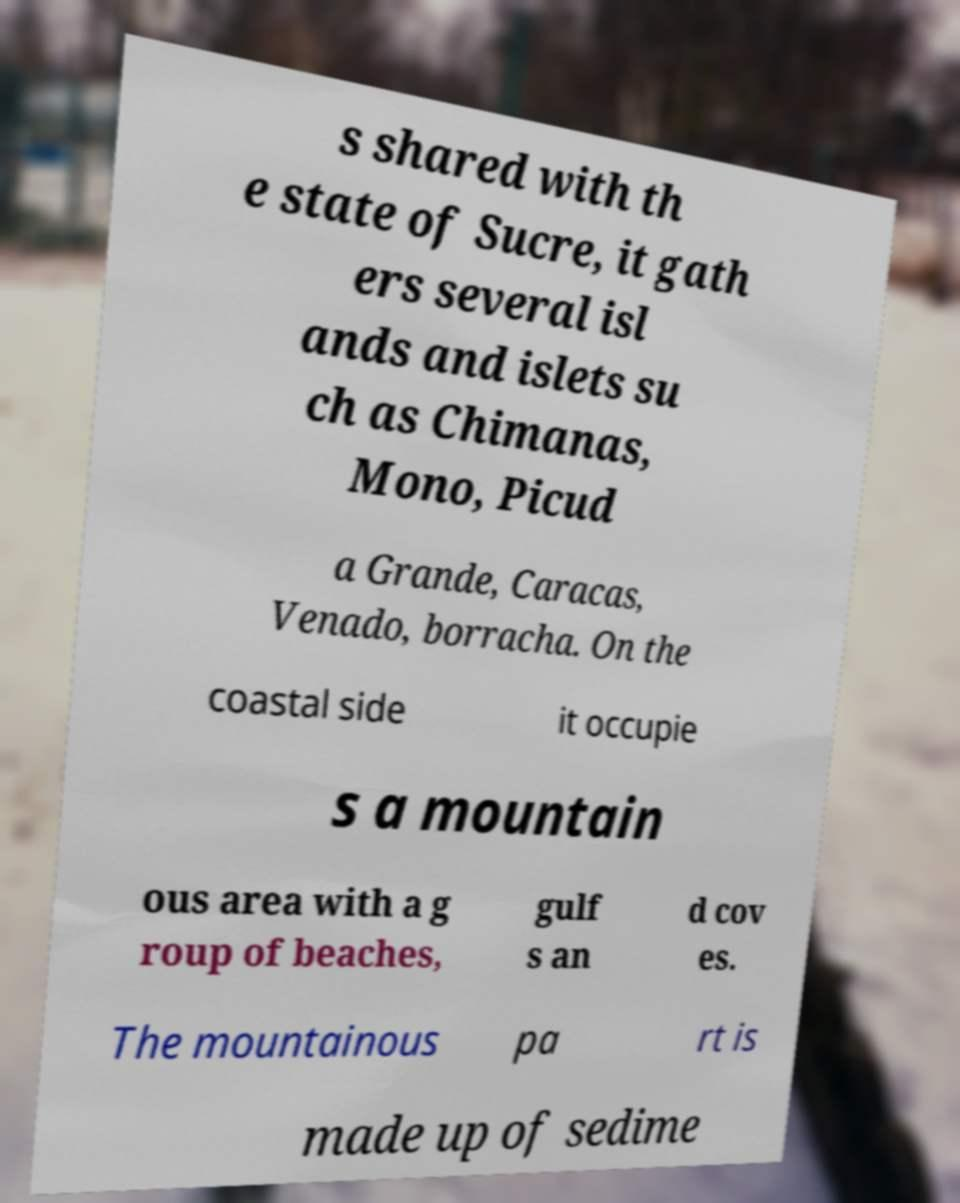Please read and relay the text visible in this image. What does it say? s shared with th e state of Sucre, it gath ers several isl ands and islets su ch as Chimanas, Mono, Picud a Grande, Caracas, Venado, borracha. On the coastal side it occupie s a mountain ous area with a g roup of beaches, gulf s an d cov es. The mountainous pa rt is made up of sedime 